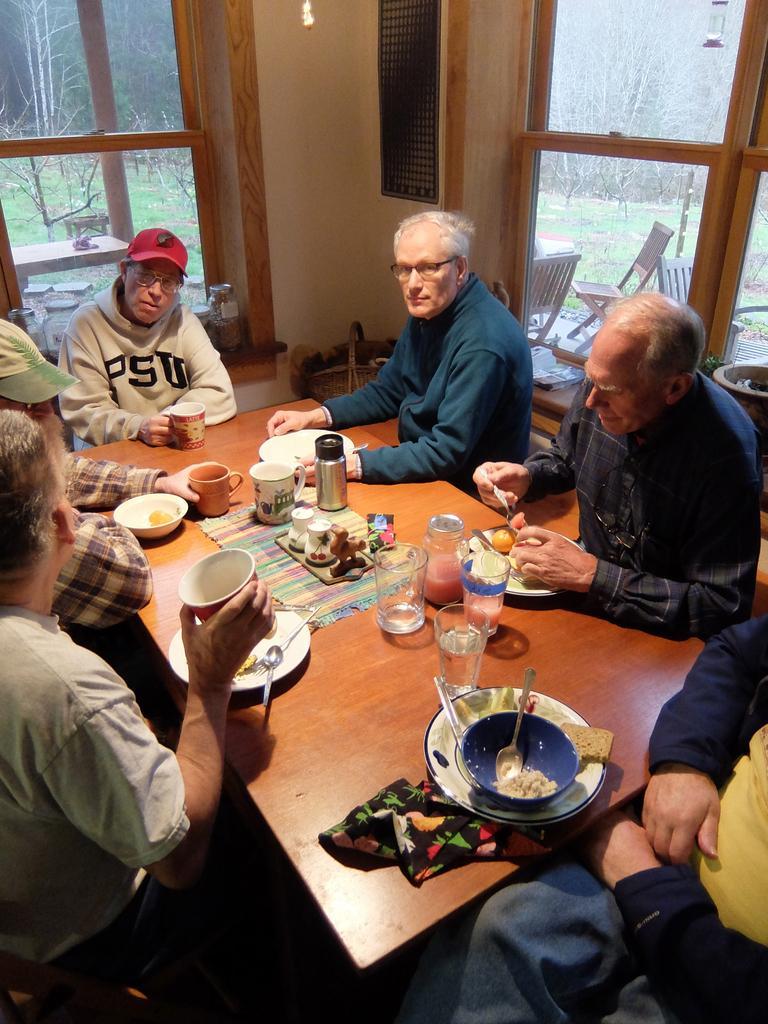Can you describe this image briefly? In this image I can see few people are sitting around this table. On this table I can see few glasses, mugs and few plates. I can also see few chairs and number of trees. 